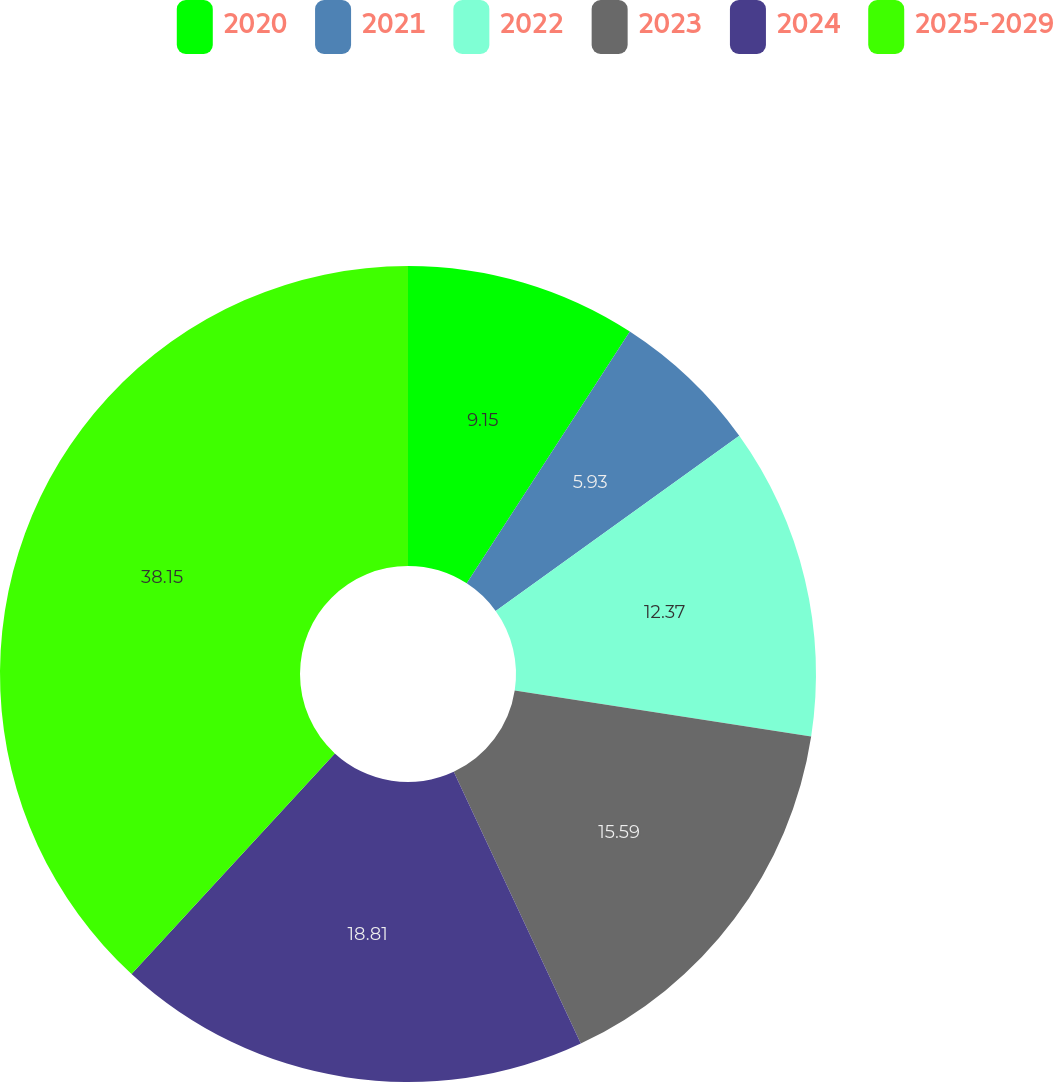Convert chart. <chart><loc_0><loc_0><loc_500><loc_500><pie_chart><fcel>2020<fcel>2021<fcel>2022<fcel>2023<fcel>2024<fcel>2025-2029<nl><fcel>9.15%<fcel>5.93%<fcel>12.37%<fcel>15.59%<fcel>18.81%<fcel>38.15%<nl></chart> 